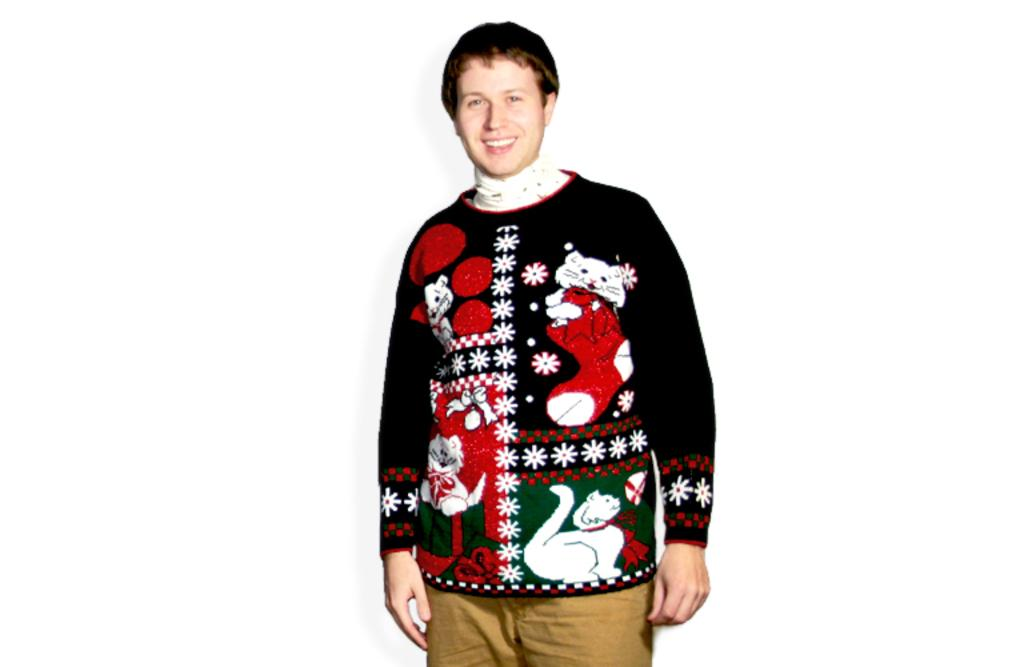Who is present in the image? There is a person in the image. What is the person wearing on their upper body? The person is wearing a black sweater. What type of pants is the person wearing? The person is wearing cream trousers. What is the color of the person's hair? The person has black hair. What is the person doing with their hands in the image? The image does not provide information about the person's hand movements. 